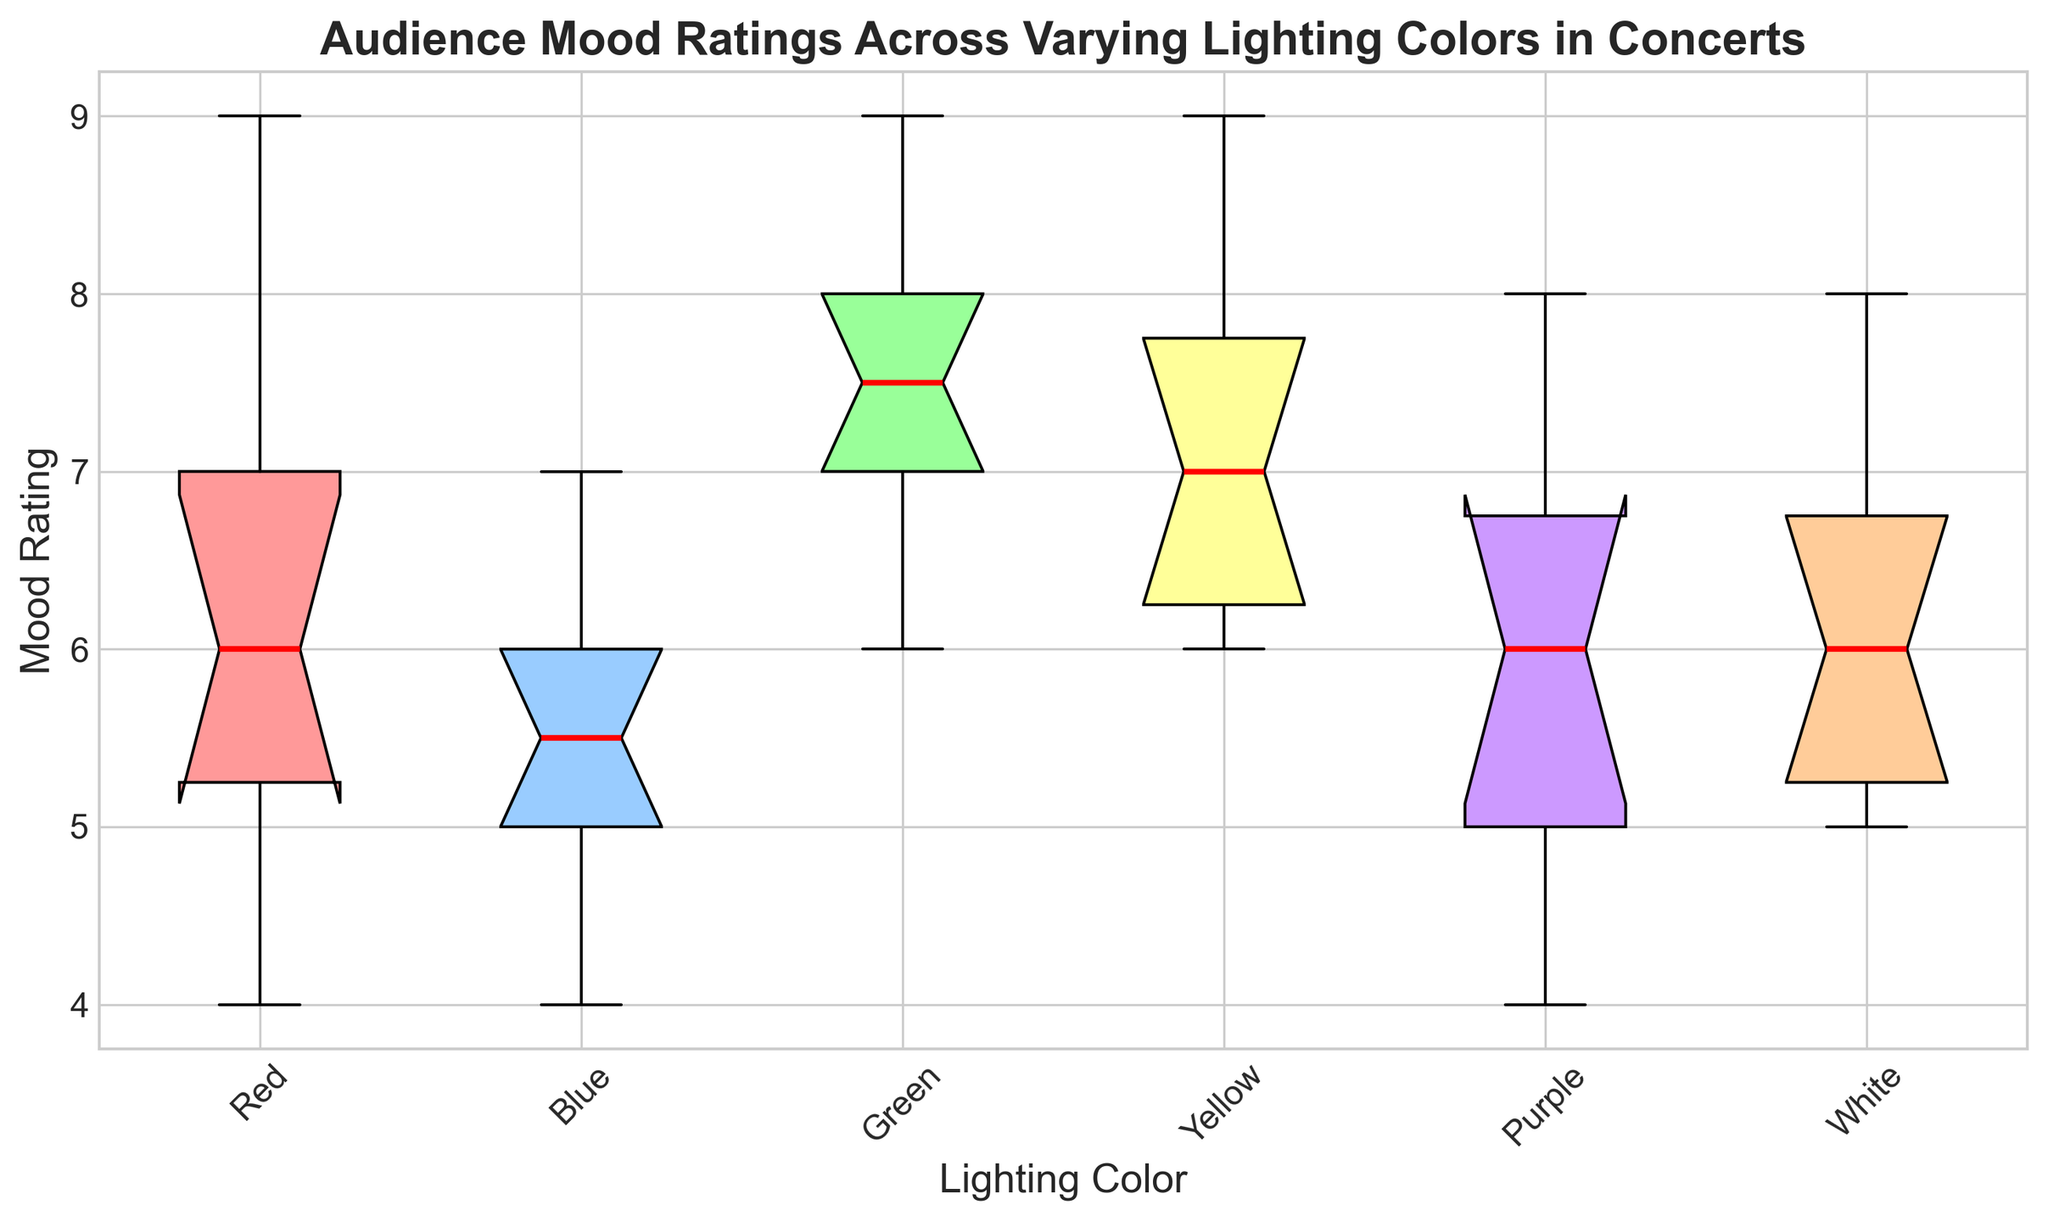What is the median mood rating for concerts with red lighting? To find the median mood rating for red lighting, locate the middle value in the box plot for the red lighting box. The median is represented by the red line within the box.
Answer: 6 Which lighting color has the highest median mood rating? Inspect the box plots and identify the median value represented by the red line within each box. The highest median mood rating is associated with the green lighting color.
Answer: Green Compare the range of mood ratings between red and purple lighting. The range is determined by the distance between the minimum and maximum values. For red, the range spans from 4 to 9, and for purple, it spans from 4 to 8. The mood rating range for red lighting is larger.
Answer: Red has a larger range Which lighting color shows the least variation in mood ratings? Variation can be assessed by the size of each box plot. The smaller the box, the less variation in the data. The yellow lighting color has the smallest box, indicating the least variation in mood ratings.
Answer: Yellow Are there any lighting colors with outlier mood ratings? How can you identify them? Outliers are often represented as individual points outside the whiskers of the box plot. Upon inspection, no outliers are present in any of the lighting colors’ mood ratings.
Answer: No outliers What is the interquartile range (IQR) for blue lighting? The IQR is the range between the first quartile (25th percentile) and the third quartile (75th percentile) of the data, represented by the box edges. For blue lighting, it spans from 5 to 6.5 (approximately).
Answer: Approximately 1.5 How does the mood rating variability of concerts with blue lighting compare to those with white lighting? Variability is represented by the spread of the box. The blue lighting mood ratings are contained in a narrower box compared to white lighting, indicating less variability for blue lighting.
Answer: Blue has less variability What are the upper and lower whisker values for yellow lighting; what do they indicate? The upper whisker represents the maximum mood rating and the lower whisker represents the minimum, excluding outliers. For yellow lighting, the whiskers span from 6 to 9. These indicate the spread of data points without extreme values.
Answer: 6 to 9 Which lighting color has the lowest minimum mood rating? Inspect the lower whiskers of each box plot. The purple lighting color has the lowest minimum mood rating, which is 4.
Answer: Purple How does the median mood rating for green lighting compare to that of white lighting? The median mood rating (red line) for green lighting is higher than that for white lighting. Specifically, the median for green is around 8, while for white, it is around 6.
Answer: Green is higher 